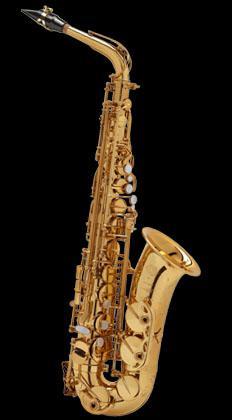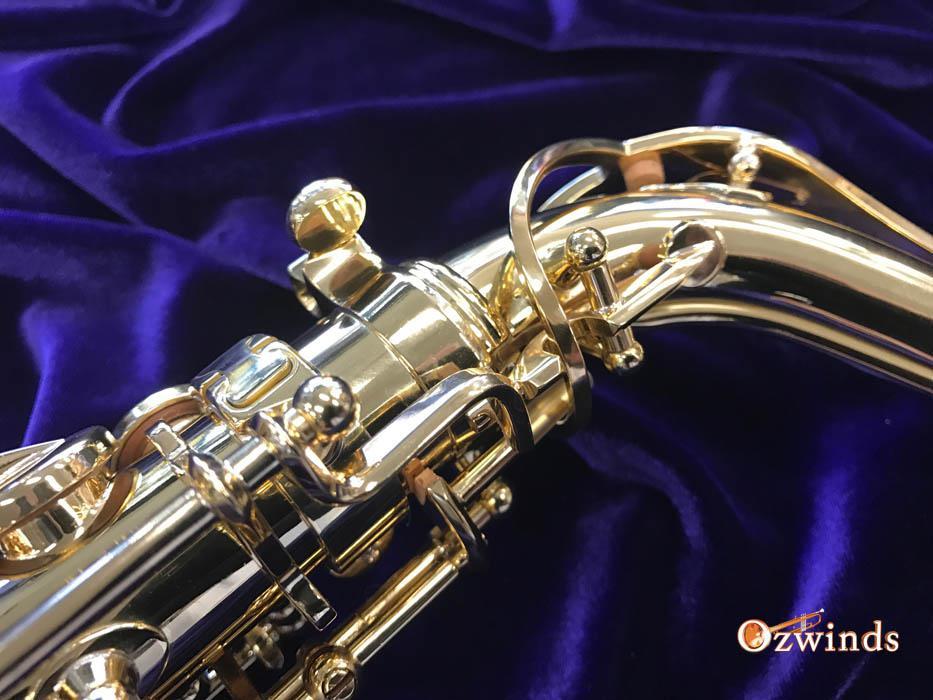The first image is the image on the left, the second image is the image on the right. Evaluate the accuracy of this statement regarding the images: "You can only see the gooseneck of one of the saxophones.". Is it true? Answer yes or no. Yes. The first image is the image on the left, the second image is the image on the right. Given the left and right images, does the statement "Each image shows a saxophone displayed on folds of blue velvet, and in one image, the bell end of the saxophone is visible and facing upward." hold true? Answer yes or no. No. 